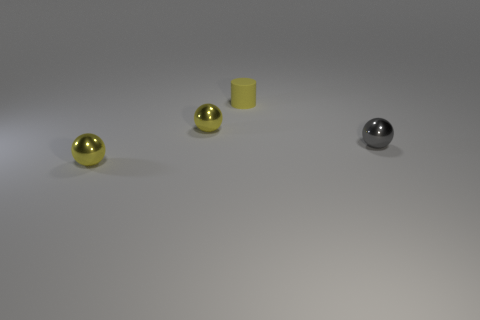Are the thing in front of the small gray object and the yellow cylinder on the left side of the tiny gray object made of the same material?
Your answer should be compact. No. There is a gray thing that is the same size as the yellow cylinder; what shape is it?
Offer a terse response. Sphere. What number of other things are the same color as the matte object?
Make the answer very short. 2. What number of cyan things are either balls or matte cylinders?
Offer a very short reply. 0. Is the shape of the metallic object right of the small cylinder the same as the tiny matte object that is behind the small gray ball?
Give a very brief answer. No. What number of other things are the same material as the yellow cylinder?
Give a very brief answer. 0. There is a yellow shiny object behind the yellow metal thing that is in front of the gray ball; is there a yellow shiny ball behind it?
Offer a very short reply. No. Are the small gray sphere and the small yellow cylinder made of the same material?
Provide a succinct answer. No. Are there any other things that are the same shape as the yellow matte object?
Your answer should be compact. No. There is a cylinder behind the metal thing right of the cylinder; what is its material?
Keep it short and to the point. Rubber. 